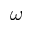<formula> <loc_0><loc_0><loc_500><loc_500>\omega</formula> 